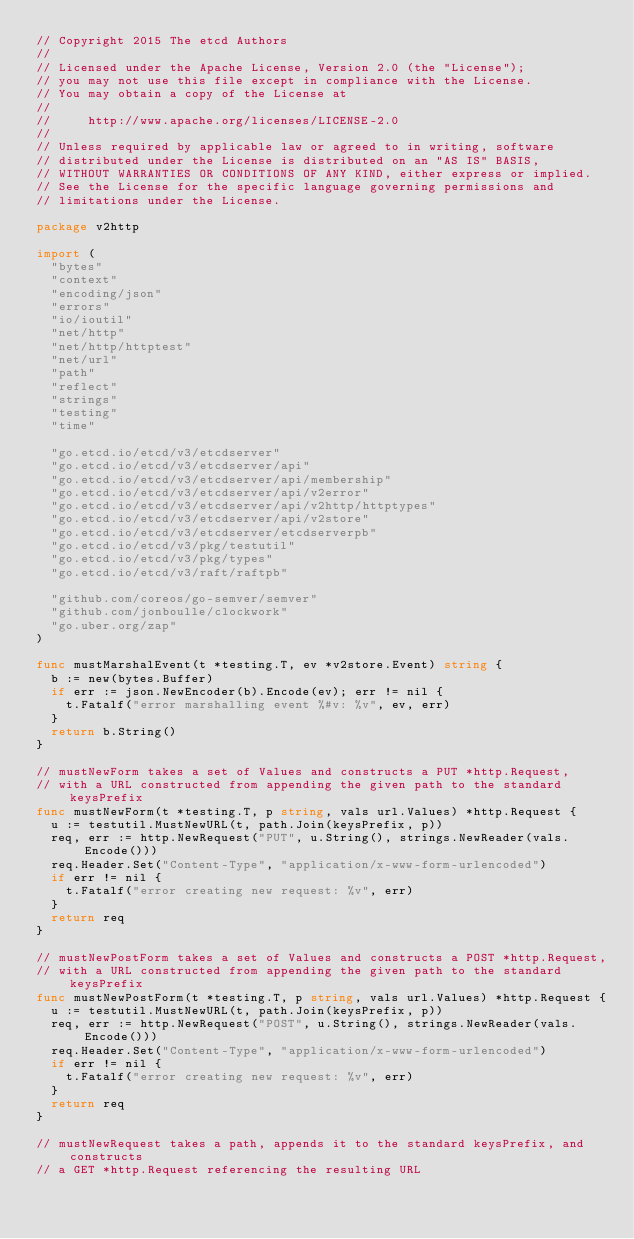Convert code to text. <code><loc_0><loc_0><loc_500><loc_500><_Go_>// Copyright 2015 The etcd Authors
//
// Licensed under the Apache License, Version 2.0 (the "License");
// you may not use this file except in compliance with the License.
// You may obtain a copy of the License at
//
//     http://www.apache.org/licenses/LICENSE-2.0
//
// Unless required by applicable law or agreed to in writing, software
// distributed under the License is distributed on an "AS IS" BASIS,
// WITHOUT WARRANTIES OR CONDITIONS OF ANY KIND, either express or implied.
// See the License for the specific language governing permissions and
// limitations under the License.

package v2http

import (
	"bytes"
	"context"
	"encoding/json"
	"errors"
	"io/ioutil"
	"net/http"
	"net/http/httptest"
	"net/url"
	"path"
	"reflect"
	"strings"
	"testing"
	"time"

	"go.etcd.io/etcd/v3/etcdserver"
	"go.etcd.io/etcd/v3/etcdserver/api"
	"go.etcd.io/etcd/v3/etcdserver/api/membership"
	"go.etcd.io/etcd/v3/etcdserver/api/v2error"
	"go.etcd.io/etcd/v3/etcdserver/api/v2http/httptypes"
	"go.etcd.io/etcd/v3/etcdserver/api/v2store"
	"go.etcd.io/etcd/v3/etcdserver/etcdserverpb"
	"go.etcd.io/etcd/v3/pkg/testutil"
	"go.etcd.io/etcd/v3/pkg/types"
	"go.etcd.io/etcd/v3/raft/raftpb"

	"github.com/coreos/go-semver/semver"
	"github.com/jonboulle/clockwork"
	"go.uber.org/zap"
)

func mustMarshalEvent(t *testing.T, ev *v2store.Event) string {
	b := new(bytes.Buffer)
	if err := json.NewEncoder(b).Encode(ev); err != nil {
		t.Fatalf("error marshalling event %#v: %v", ev, err)
	}
	return b.String()
}

// mustNewForm takes a set of Values and constructs a PUT *http.Request,
// with a URL constructed from appending the given path to the standard keysPrefix
func mustNewForm(t *testing.T, p string, vals url.Values) *http.Request {
	u := testutil.MustNewURL(t, path.Join(keysPrefix, p))
	req, err := http.NewRequest("PUT", u.String(), strings.NewReader(vals.Encode()))
	req.Header.Set("Content-Type", "application/x-www-form-urlencoded")
	if err != nil {
		t.Fatalf("error creating new request: %v", err)
	}
	return req
}

// mustNewPostForm takes a set of Values and constructs a POST *http.Request,
// with a URL constructed from appending the given path to the standard keysPrefix
func mustNewPostForm(t *testing.T, p string, vals url.Values) *http.Request {
	u := testutil.MustNewURL(t, path.Join(keysPrefix, p))
	req, err := http.NewRequest("POST", u.String(), strings.NewReader(vals.Encode()))
	req.Header.Set("Content-Type", "application/x-www-form-urlencoded")
	if err != nil {
		t.Fatalf("error creating new request: %v", err)
	}
	return req
}

// mustNewRequest takes a path, appends it to the standard keysPrefix, and constructs
// a GET *http.Request referencing the resulting URL</code> 